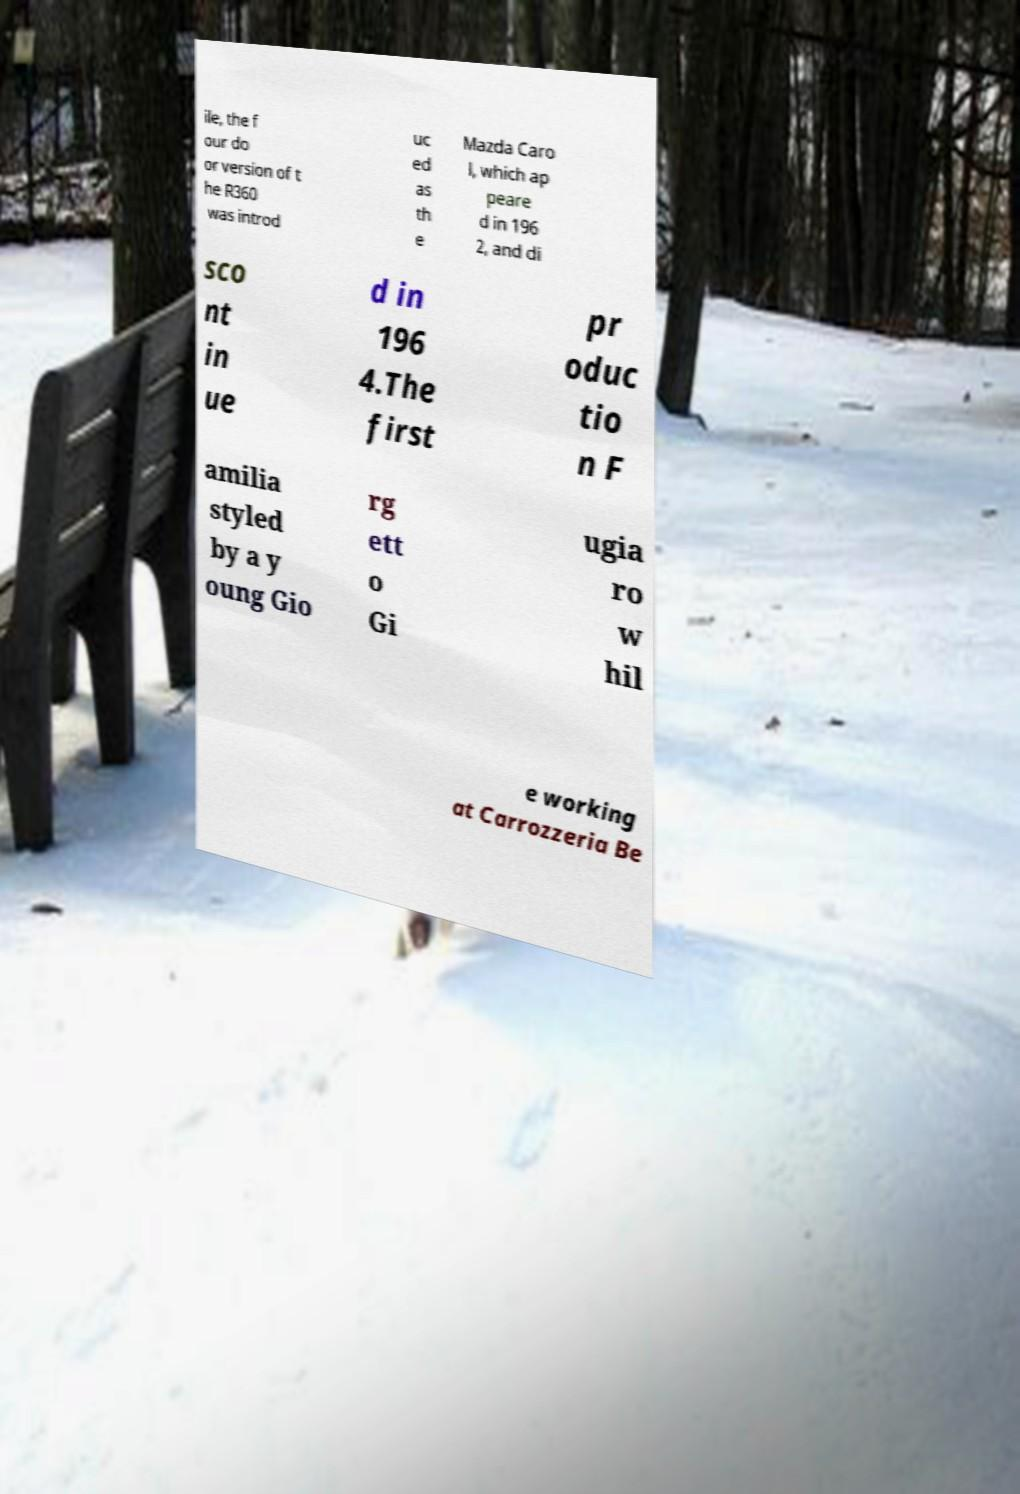There's text embedded in this image that I need extracted. Can you transcribe it verbatim? ile, the f our do or version of t he R360 was introd uc ed as th e Mazda Caro l, which ap peare d in 196 2, and di sco nt in ue d in 196 4.The first pr oduc tio n F amilia styled by a y oung Gio rg ett o Gi ugia ro w hil e working at Carrozzeria Be 